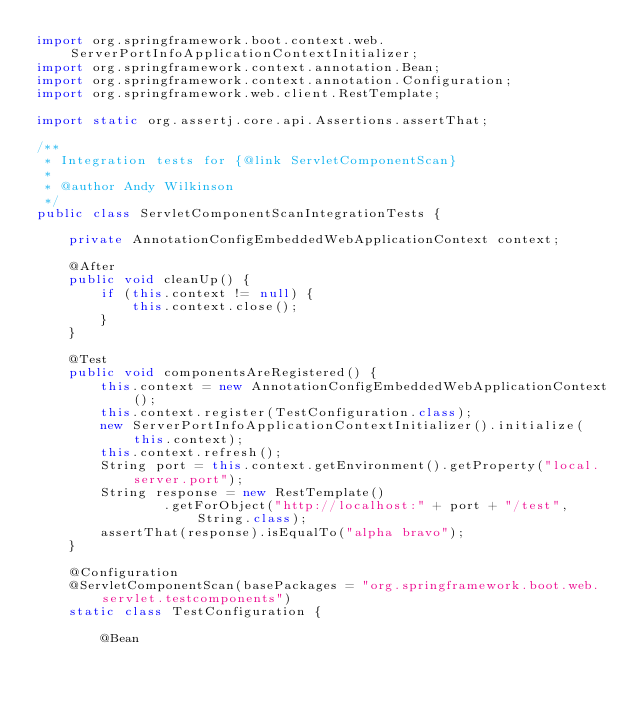Convert code to text. <code><loc_0><loc_0><loc_500><loc_500><_Java_>import org.springframework.boot.context.web.ServerPortInfoApplicationContextInitializer;
import org.springframework.context.annotation.Bean;
import org.springframework.context.annotation.Configuration;
import org.springframework.web.client.RestTemplate;

import static org.assertj.core.api.Assertions.assertThat;

/**
 * Integration tests for {@link ServletComponentScan}
 *
 * @author Andy Wilkinson
 */
public class ServletComponentScanIntegrationTests {

	private AnnotationConfigEmbeddedWebApplicationContext context;

	@After
	public void cleanUp() {
		if (this.context != null) {
			this.context.close();
		}
	}

	@Test
	public void componentsAreRegistered() {
		this.context = new AnnotationConfigEmbeddedWebApplicationContext();
		this.context.register(TestConfiguration.class);
		new ServerPortInfoApplicationContextInitializer().initialize(this.context);
		this.context.refresh();
		String port = this.context.getEnvironment().getProperty("local.server.port");
		String response = new RestTemplate()
				.getForObject("http://localhost:" + port + "/test", String.class);
		assertThat(response).isEqualTo("alpha bravo");
	}

	@Configuration
	@ServletComponentScan(basePackages = "org.springframework.boot.web.servlet.testcomponents")
	static class TestConfiguration {

		@Bean</code> 